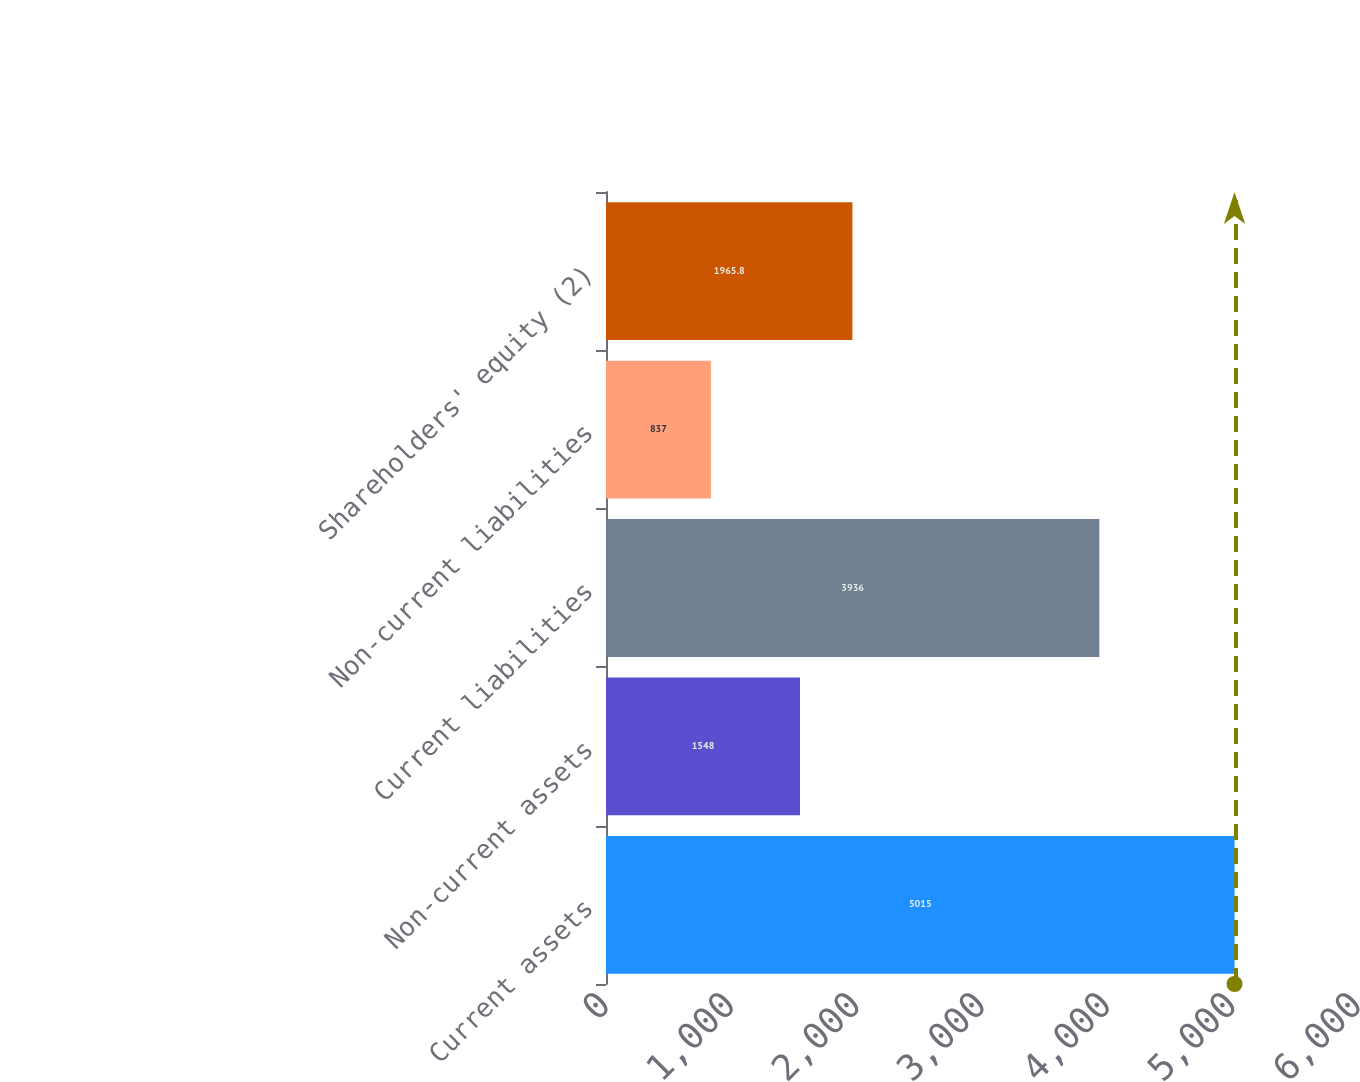Convert chart. <chart><loc_0><loc_0><loc_500><loc_500><bar_chart><fcel>Current assets<fcel>Non-current assets<fcel>Current liabilities<fcel>Non-current liabilities<fcel>Shareholders' equity (2)<nl><fcel>5015<fcel>1548<fcel>3936<fcel>837<fcel>1965.8<nl></chart> 